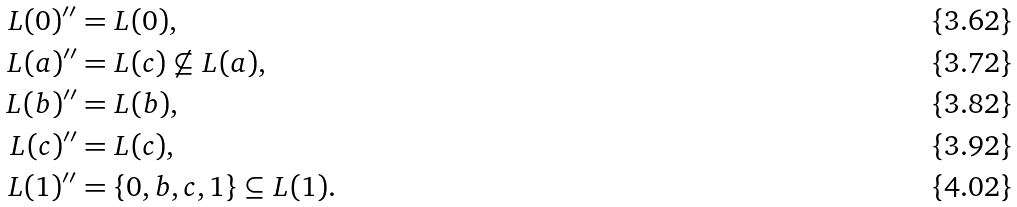<formula> <loc_0><loc_0><loc_500><loc_500>L ( 0 ) ^ { \prime \prime } & = L ( 0 ) , \\ L ( a ) ^ { \prime \prime } & = L ( c ) \not \subseteq L ( a ) , \\ L ( b ) ^ { \prime \prime } & = L ( b ) , \\ L ( c ) ^ { \prime \prime } & = L ( c ) , \\ L ( 1 ) ^ { \prime \prime } & = \{ 0 , b , c , 1 \} \subseteq L ( 1 ) .</formula> 